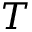Convert formula to latex. <formula><loc_0><loc_0><loc_500><loc_500>T</formula> 